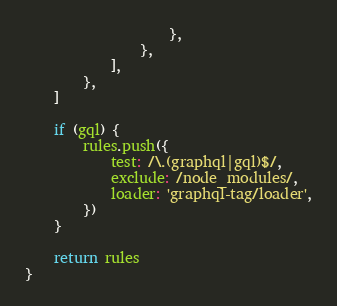<code> <loc_0><loc_0><loc_500><loc_500><_JavaScript_>                    },
                },
            ],
        },
    ]

    if (gql) {
        rules.push({
            test: /\.(graphql|gql)$/,
            exclude: /node_modules/,
            loader: 'graphql-tag/loader',
        })
    }

    return rules
}
</code> 